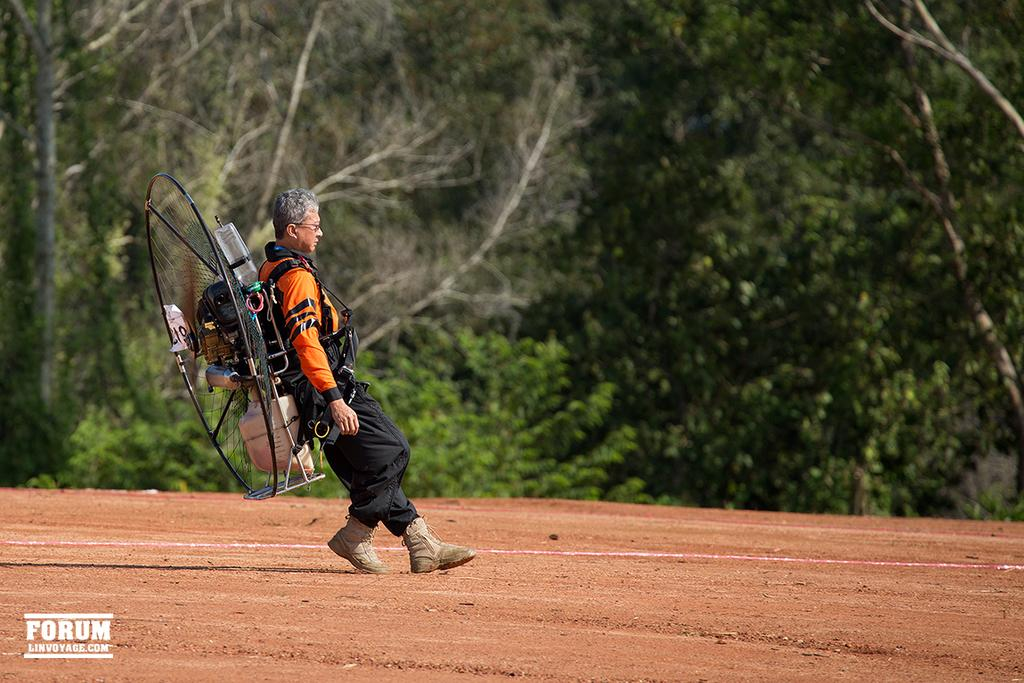What is the main subject of the image? The main subject of the image is a man. What is the man wearing in the image? The man is wearing a machine-like object. What can be seen in the background of the image? There are trees in the background of the image. Can you describe any additional features of the image? There is a watermark in the image. What type of cap can be seen on the man's head in the image? There is no cap visible on the man's head in the image; he is wearing a machine-like object. How many grapes are hanging from the trees in the background of the image? There are no grapes visible in the image; only trees are present in the background. 